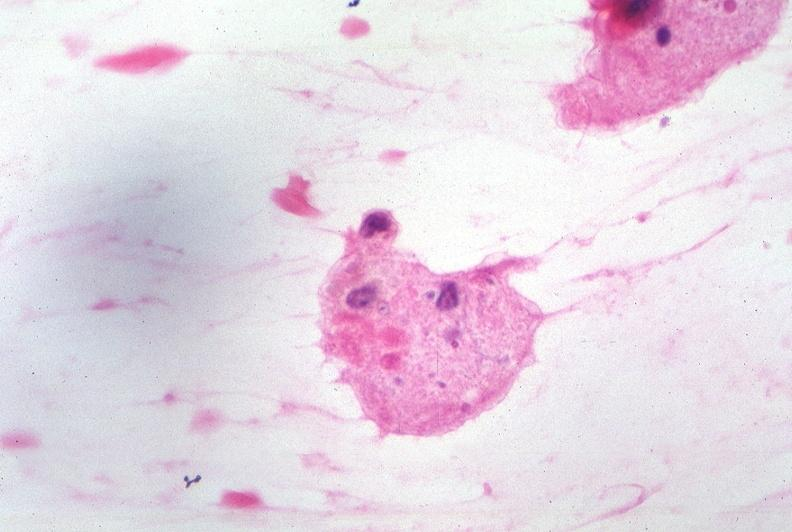what is present?
Answer the question using a single word or phrase. Nervous 